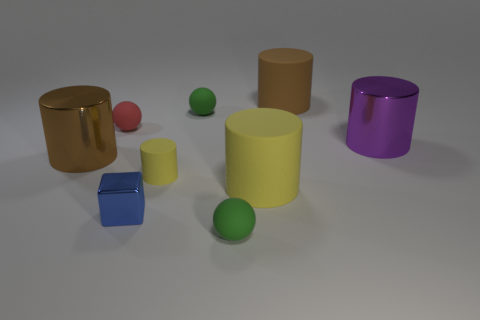There is a yellow object that is on the right side of the small green thing on the right side of the small rubber ball that is behind the red rubber sphere; how big is it?
Ensure brevity in your answer.  Large. What size is the brown cylinder that is made of the same material as the large yellow thing?
Your answer should be compact. Large. The object that is both behind the purple metallic cylinder and on the left side of the blue object is what color?
Ensure brevity in your answer.  Red. Is the shape of the brown object behind the large purple cylinder the same as the large shiny thing that is right of the small metal thing?
Your answer should be compact. Yes. What material is the small ball left of the small yellow cylinder?
Ensure brevity in your answer.  Rubber. What size is the object that is the same color as the tiny matte cylinder?
Ensure brevity in your answer.  Large. How many things are either brown cylinders behind the tiny red matte object or tiny spheres?
Keep it short and to the point. 4. Is the number of large brown shiny cylinders that are in front of the big yellow rubber thing the same as the number of big red metal cubes?
Provide a succinct answer. Yes. Is the size of the red matte object the same as the purple object?
Provide a short and direct response. No. What color is the shiny object that is the same size as the brown metallic cylinder?
Offer a terse response. Purple. 